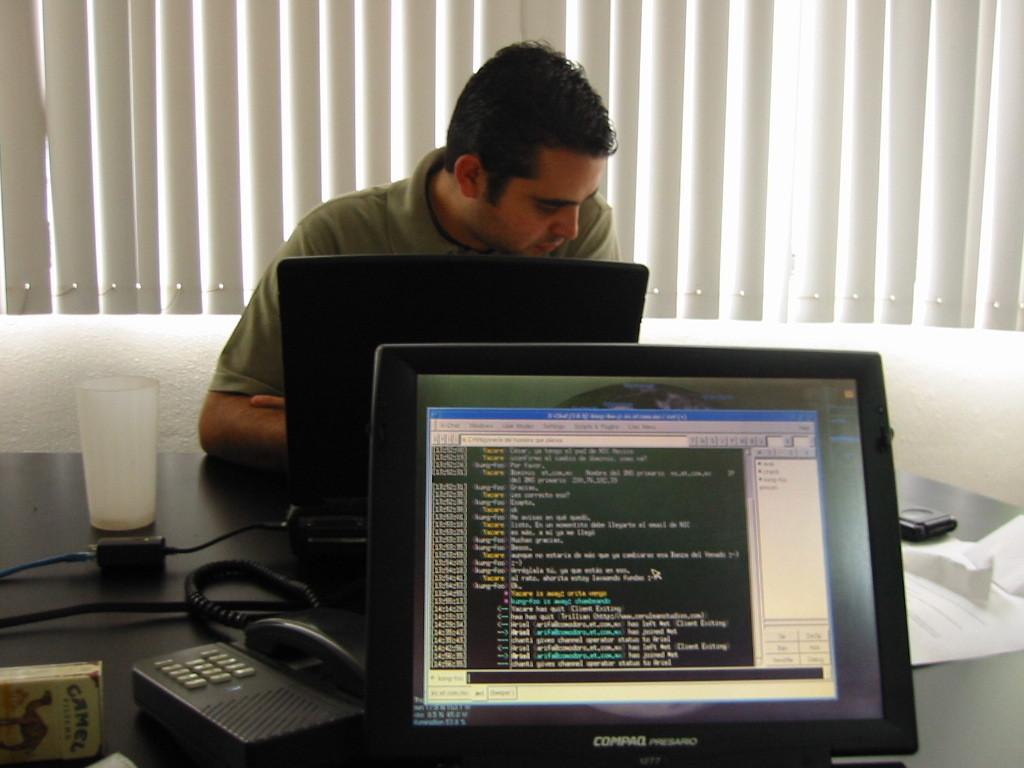Provide a one-sentence caption for the provided image. guy using a computer and another compaq presario computer that has app open but no one at it. 